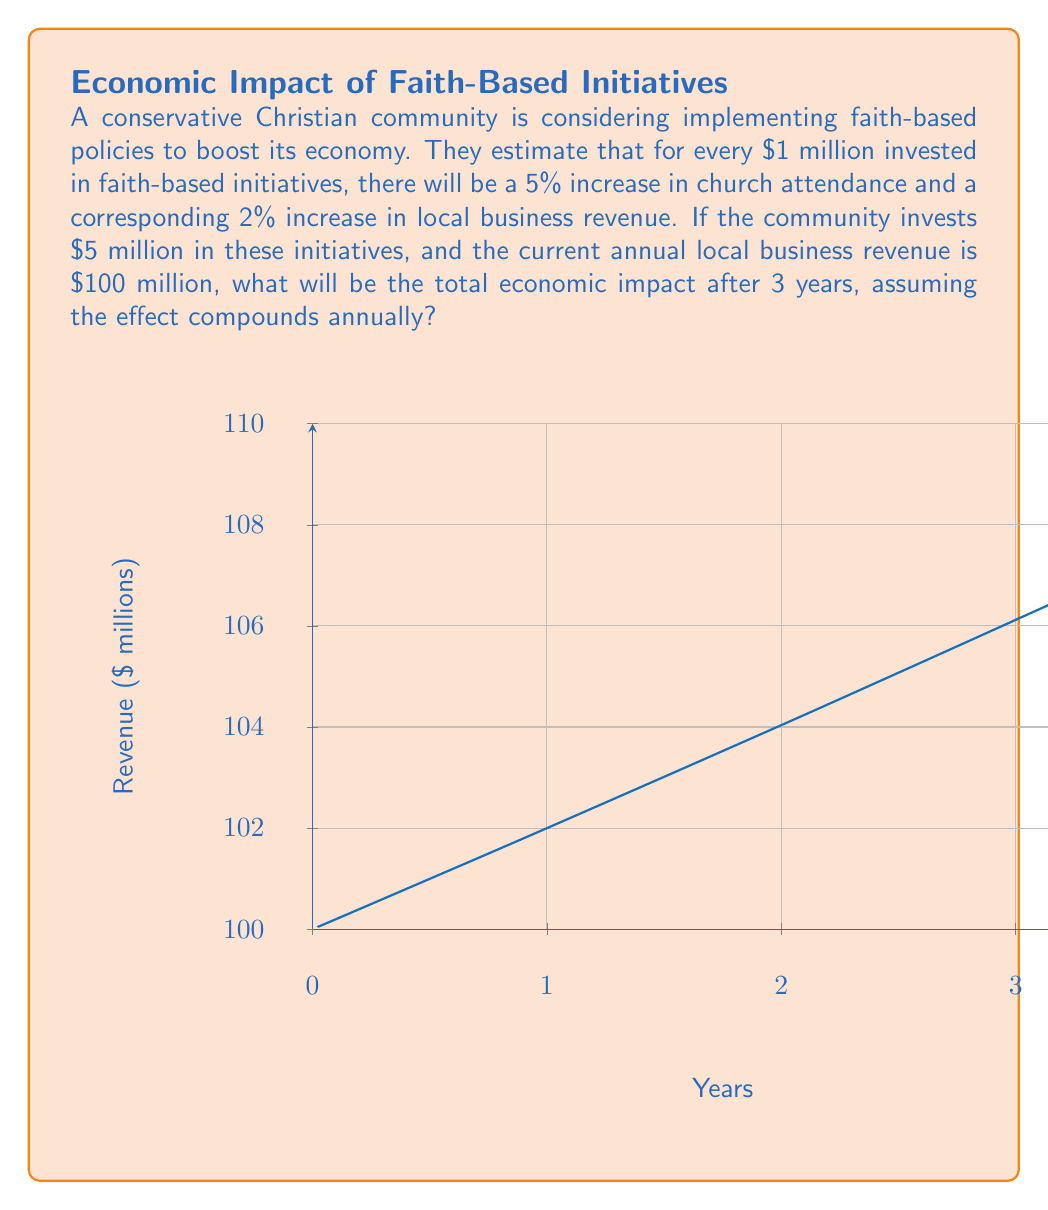Help me with this question. Let's approach this step-by-step:

1) The investment is $5 million, which is 5 times the base unit of $1 million.

2) For each $1 million invested, there's a 2% increase in local business revenue. So for $5 million, we expect a 5 * 2% = 10% increase per year.

3) We need to calculate the compound effect over 3 years. Let's use the compound interest formula:

   $$A = P(1 + r)^n$$

   Where:
   A = Final amount
   P = Principal (initial amount)
   r = Annual rate of increase (as a decimal)
   n = Number of years

4) In this case:
   P = $100 million (initial revenue)
   r = 0.10 (10% increase per year)
   n = 3 years

5) Plugging these values into the formula:

   $$A = 100,000,000 * (1 + 0.10)^3$$

6) Calculating:
   $$A = 100,000,000 * (1.1)^3$$
   $$A = 100,000,000 * 1.331$$
   $$A = 133,100,000$$

7) The total economic impact is the difference between the final amount and the initial amount:

   $133,100,000 - $100,000,000 = $33,100,000
Answer: $33.1 million 